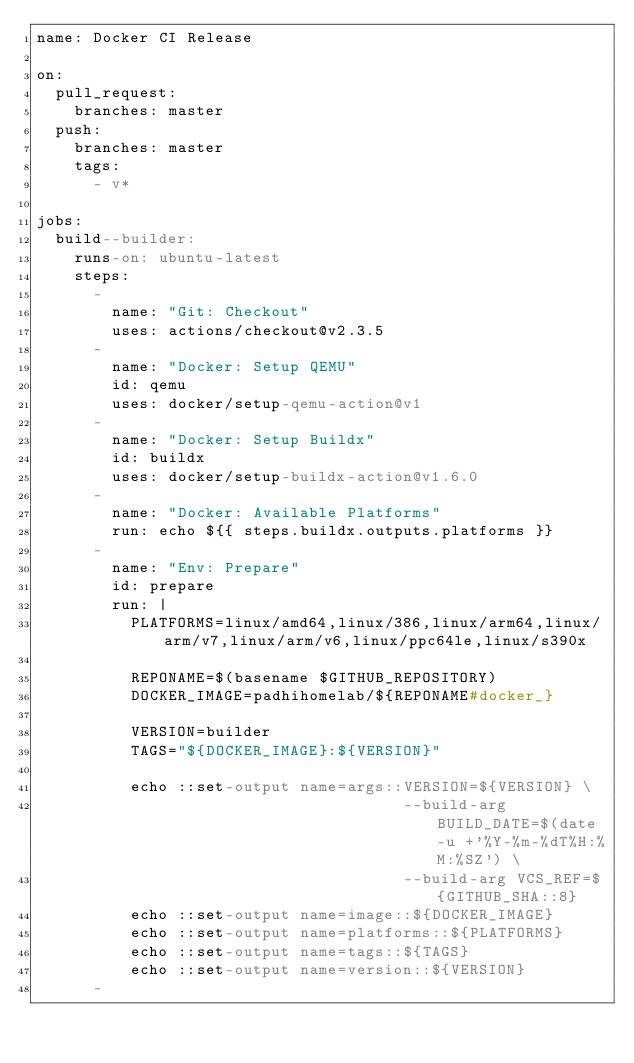Convert code to text. <code><loc_0><loc_0><loc_500><loc_500><_YAML_>name: Docker CI Release

on:
  pull_request:
    branches: master
  push:
    branches: master
    tags:
      - v*

jobs:
  build--builder:
    runs-on: ubuntu-latest
    steps:
      -
        name: "Git: Checkout"
        uses: actions/checkout@v2.3.5
      -
        name: "Docker: Setup QEMU"
        id: qemu
        uses: docker/setup-qemu-action@v1
      -
        name: "Docker: Setup Buildx"
        id: buildx
        uses: docker/setup-buildx-action@v1.6.0
      -
        name: "Docker: Available Platforms"
        run: echo ${{ steps.buildx.outputs.platforms }}
      -
        name: "Env: Prepare"
        id: prepare
        run: |
          PLATFORMS=linux/amd64,linux/386,linux/arm64,linux/arm/v7,linux/arm/v6,linux/ppc64le,linux/s390x

          REPONAME=$(basename $GITHUB_REPOSITORY)
          DOCKER_IMAGE=padhihomelab/${REPONAME#docker_}

          VERSION=builder
          TAGS="${DOCKER_IMAGE}:${VERSION}"

          echo ::set-output name=args::VERSION=${VERSION} \
                                       --build-arg BUILD_DATE=$(date -u +'%Y-%m-%dT%H:%M:%SZ') \
                                       --build-arg VCS_REF=${GITHUB_SHA::8}
          echo ::set-output name=image::${DOCKER_IMAGE}
          echo ::set-output name=platforms::${PLATFORMS}
          echo ::set-output name=tags::${TAGS}
          echo ::set-output name=version::${VERSION}
      -</code> 